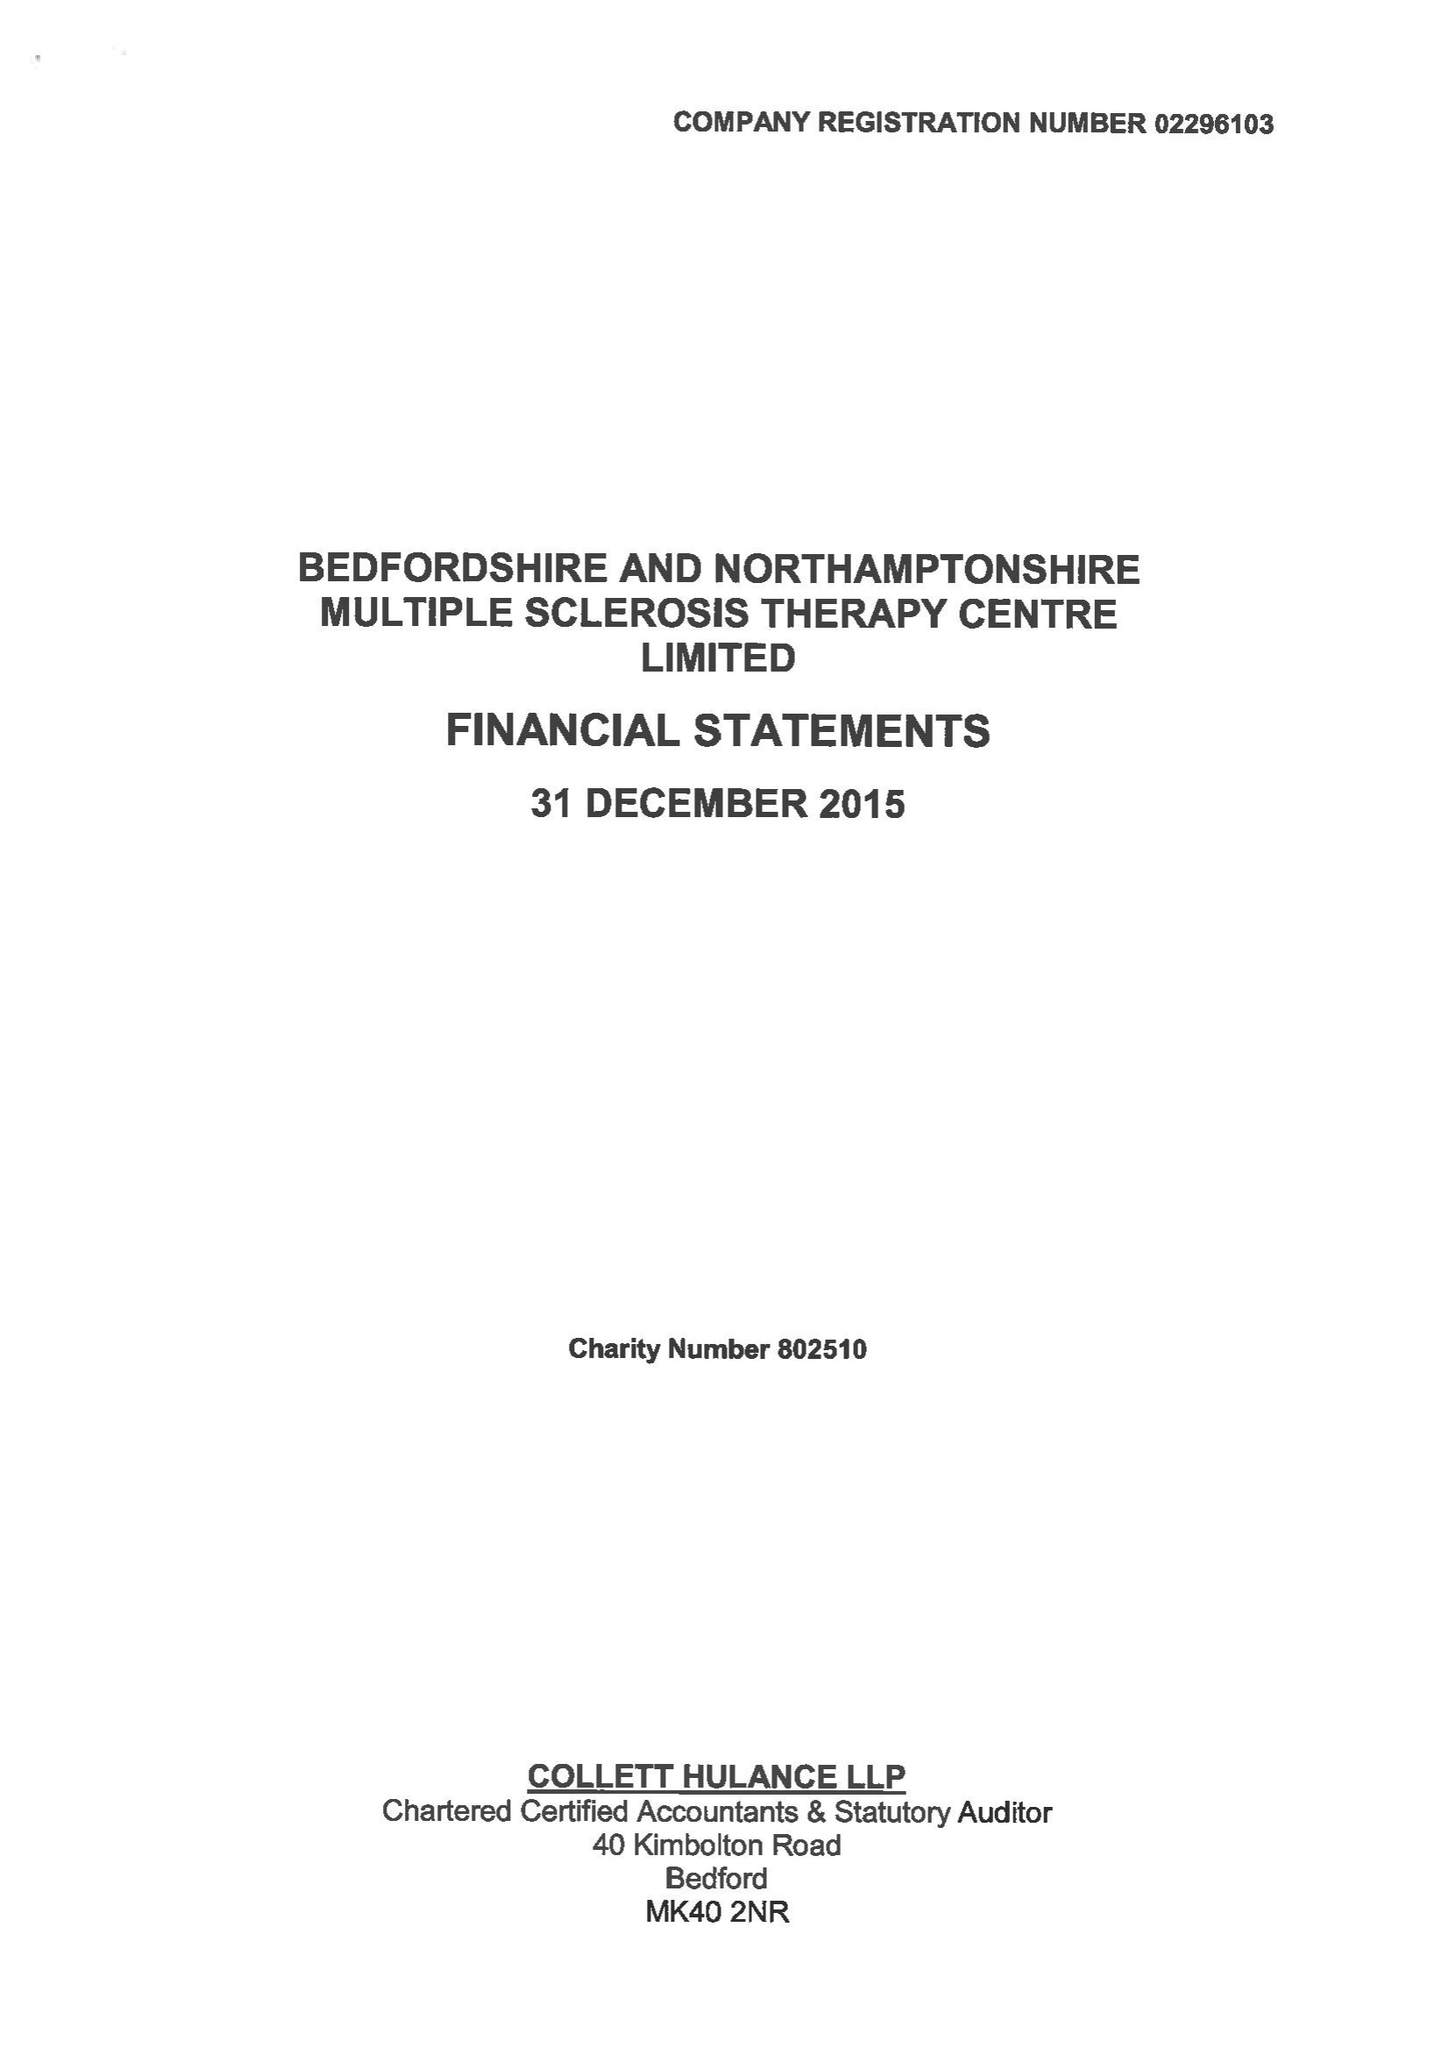What is the value for the report_date?
Answer the question using a single word or phrase. 2015-12-31 